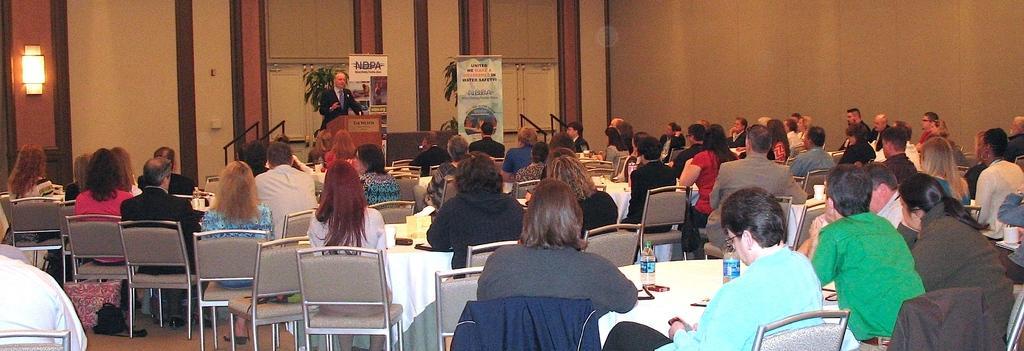In one or two sentences, can you explain what this image depicts? In the image we can see there are lot of people who are sitting on chair and there is a man who is standing here. 